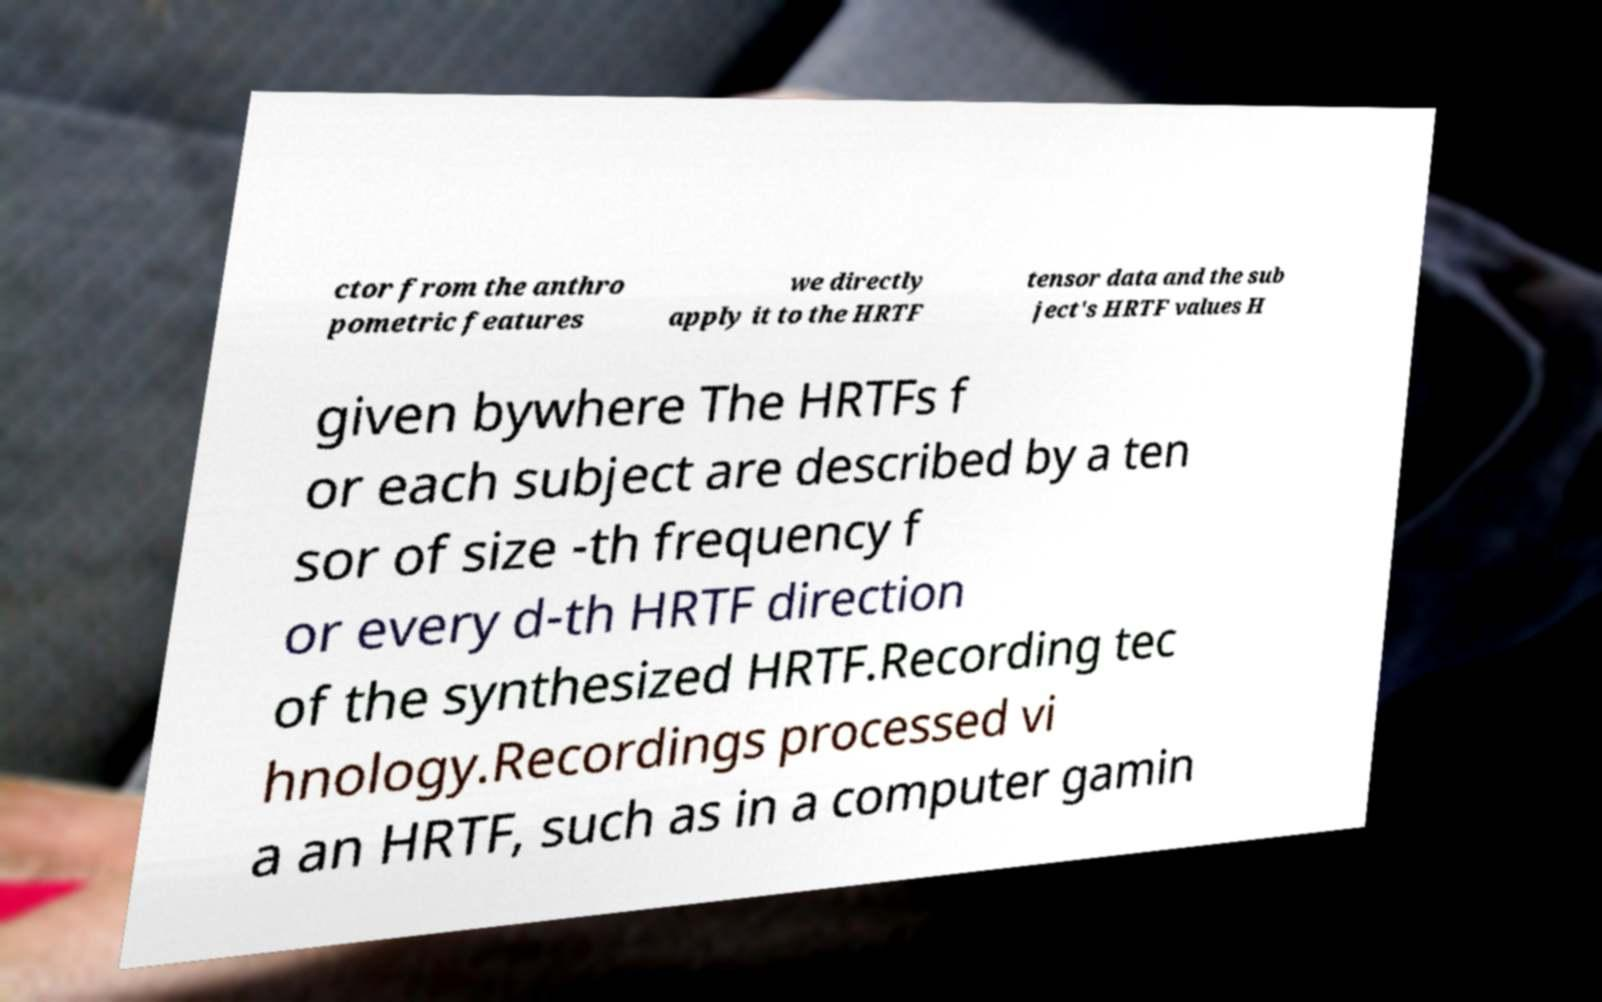Can you accurately transcribe the text from the provided image for me? ctor from the anthro pometric features we directly apply it to the HRTF tensor data and the sub ject's HRTF values H given bywhere The HRTFs f or each subject are described by a ten sor of size -th frequency f or every d-th HRTF direction of the synthesized HRTF.Recording tec hnology.Recordings processed vi a an HRTF, such as in a computer gamin 